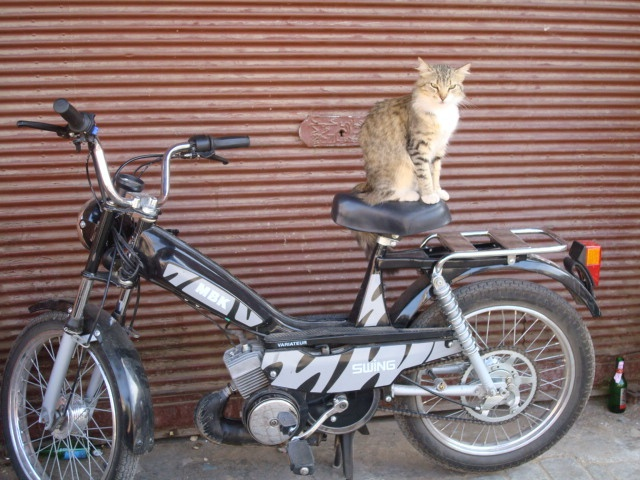Describe the objects in this image and their specific colors. I can see motorcycle in gray, darkgray, black, and lightgray tones, cat in gray, ivory, and tan tones, and bottle in gray, black, lavender, and darkgray tones in this image. 